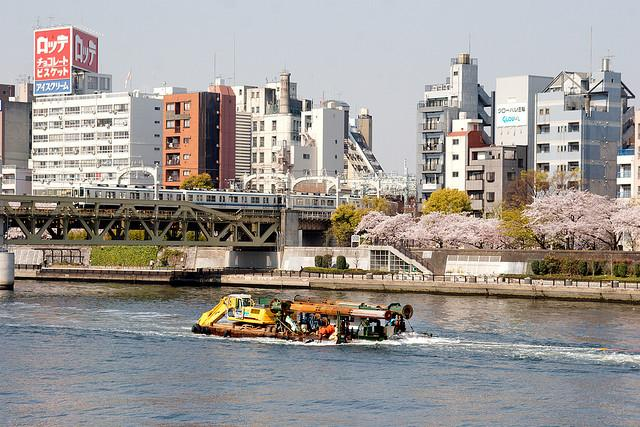What type of area is nearby?

Choices:
A) rural
B) country
C) urban
D) tropical urban 